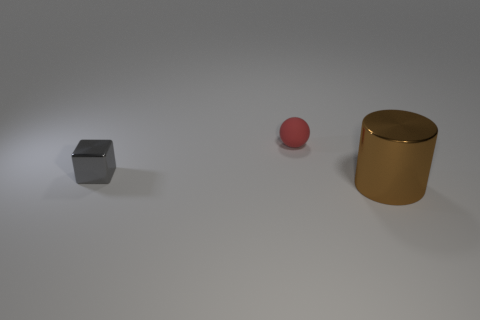Add 3 small cyan blocks. How many objects exist? 6 Subtract all big gray matte things. Subtract all metallic objects. How many objects are left? 1 Add 3 cylinders. How many cylinders are left? 4 Add 1 large shiny objects. How many large shiny objects exist? 2 Subtract 0 gray balls. How many objects are left? 3 Subtract all cylinders. How many objects are left? 2 